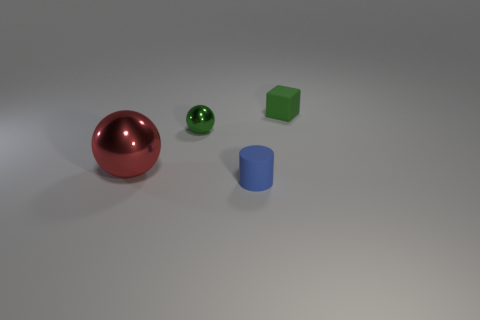What number of other objects are the same shape as the red shiny thing?
Your answer should be very brief. 1. What color is the tiny matte thing in front of the tiny sphere left of the green thing that is on the right side of the small blue object?
Offer a terse response. Blue. How many cyan matte things are there?
Keep it short and to the point. 0. What number of big objects are green rubber objects or blue rubber cylinders?
Offer a terse response. 0. The blue rubber object that is the same size as the matte cube is what shape?
Offer a very short reply. Cylinder. Is there any other thing that has the same size as the green sphere?
Your answer should be compact. Yes. There is a object behind the ball that is to the right of the big red object; what is its material?
Your answer should be compact. Rubber. Is the size of the block the same as the red shiny object?
Provide a short and direct response. No. How many things are either small rubber objects in front of the green matte thing or tiny green rubber blocks?
Ensure brevity in your answer.  2. What is the shape of the tiny matte object that is in front of the large red metal thing that is to the left of the block?
Offer a very short reply. Cylinder. 